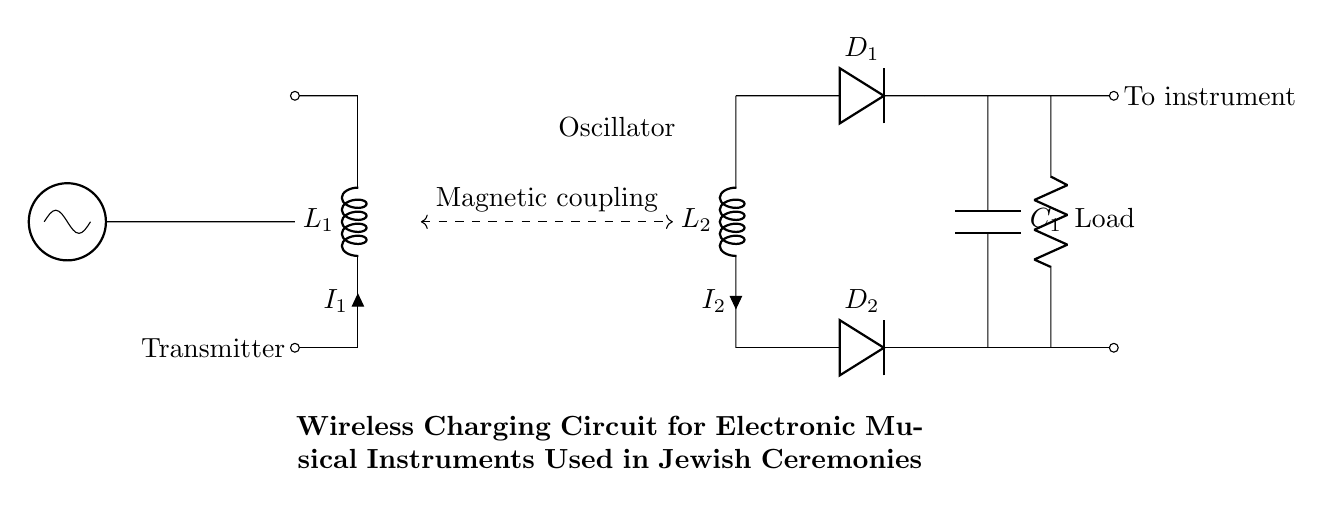What type of circuit is depicted? The diagram represents a wireless charging circuit specifically designed for electronic musical instruments used in Jewish ceremonies. This conclusion is drawn from the title that explicitly states the function and intended application of the circuit.
Answer: Wireless charging What components are involved? The circuit includes an oscillator, two inductors (L1 and L2), two diodes (D1 and D2), a smoothing capacitor (C1), and a load resistor labeled 'Load'. These components are visualized in the circuit diagram and their labels assist in identifying their roles.
Answer: Oscillator, inductors, diodes, capacitor, load resistor How is the power transferred in this circuit? Power is transferred through magnetic coupling between the transmitter coil (L1) and the receiver coil (L2). This is indicated by the dashed line connecting the two coils and labeled "Magnetic coupling" in the diagram.
Answer: Magnetic coupling Which component stores energy in this circuit? The smoothing capacitor (C1) stores energy. The presence of a capacitor in the circuit is aimed at reducing voltage fluctuations and providing a stable output, which is evident from its placement in the circuit diagram after rectification.
Answer: Capacitor What is the role of the diodes in this circuit? The diodes (D1 and D2) serve as rectifiers, allowing current to flow in one direction only. This is crucial for converting the alternating current generated in the receiver coil into direct current suitable for the load. Their positions in the circuit indicate this purpose.
Answer: Rectification What is the load in this circuit? The load in this circuit is simply labeled 'Load', which represents the electronic instrument being powered by the wireless charging circuit. It appears at the output side of the circuit, indicating where the powered device connects.
Answer: Electronic instrument How many coils are present in this circuit? There are two coils in the circuit, indicated as L1 and L2, which are designated as the transmitter and receiver coils, respectively. The diagram clearly shows both coils and their respective labels.
Answer: Two coils 